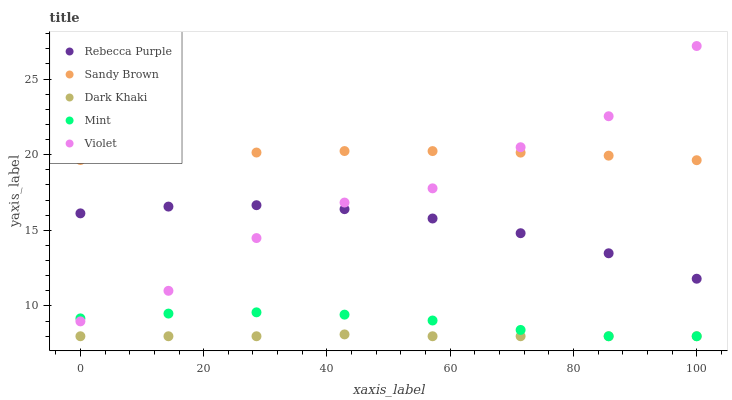Does Dark Khaki have the minimum area under the curve?
Answer yes or no. Yes. Does Sandy Brown have the maximum area under the curve?
Answer yes or no. Yes. Does Mint have the minimum area under the curve?
Answer yes or no. No. Does Mint have the maximum area under the curve?
Answer yes or no. No. Is Dark Khaki the smoothest?
Answer yes or no. Yes. Is Violet the roughest?
Answer yes or no. Yes. Is Mint the smoothest?
Answer yes or no. No. Is Mint the roughest?
Answer yes or no. No. Does Dark Khaki have the lowest value?
Answer yes or no. Yes. Does Sandy Brown have the lowest value?
Answer yes or no. No. Does Violet have the highest value?
Answer yes or no. Yes. Does Mint have the highest value?
Answer yes or no. No. Is Rebecca Purple less than Sandy Brown?
Answer yes or no. Yes. Is Rebecca Purple greater than Mint?
Answer yes or no. Yes. Does Violet intersect Rebecca Purple?
Answer yes or no. Yes. Is Violet less than Rebecca Purple?
Answer yes or no. No. Is Violet greater than Rebecca Purple?
Answer yes or no. No. Does Rebecca Purple intersect Sandy Brown?
Answer yes or no. No. 